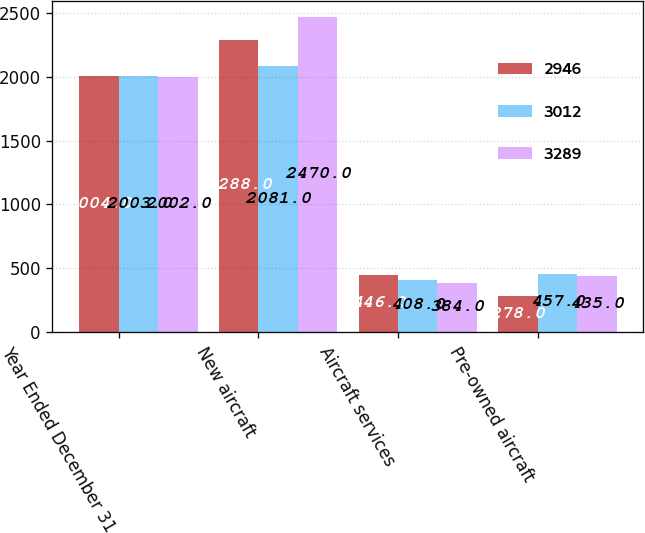<chart> <loc_0><loc_0><loc_500><loc_500><stacked_bar_chart><ecel><fcel>Year Ended December 31<fcel>New aircraft<fcel>Aircraft services<fcel>Pre-owned aircraft<nl><fcel>2946<fcel>2004<fcel>2288<fcel>446<fcel>278<nl><fcel>3012<fcel>2003<fcel>2081<fcel>408<fcel>457<nl><fcel>3289<fcel>2002<fcel>2470<fcel>384<fcel>435<nl></chart> 